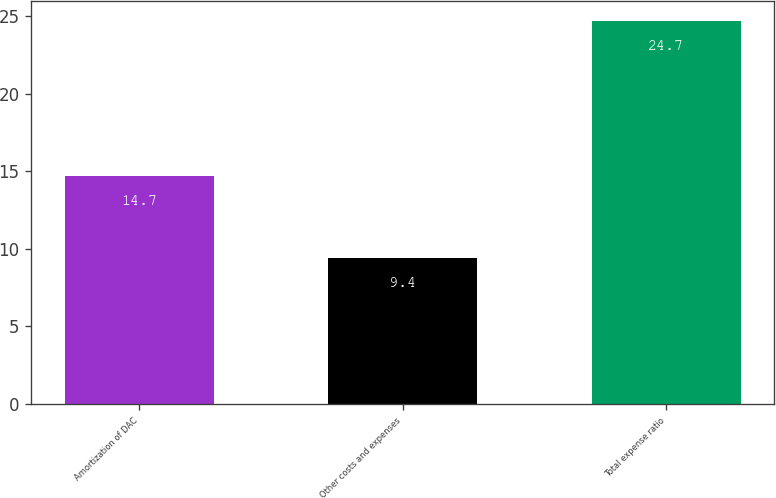Convert chart. <chart><loc_0><loc_0><loc_500><loc_500><bar_chart><fcel>Amortization of DAC<fcel>Other costs and expenses<fcel>Total expense ratio<nl><fcel>14.7<fcel>9.4<fcel>24.7<nl></chart> 